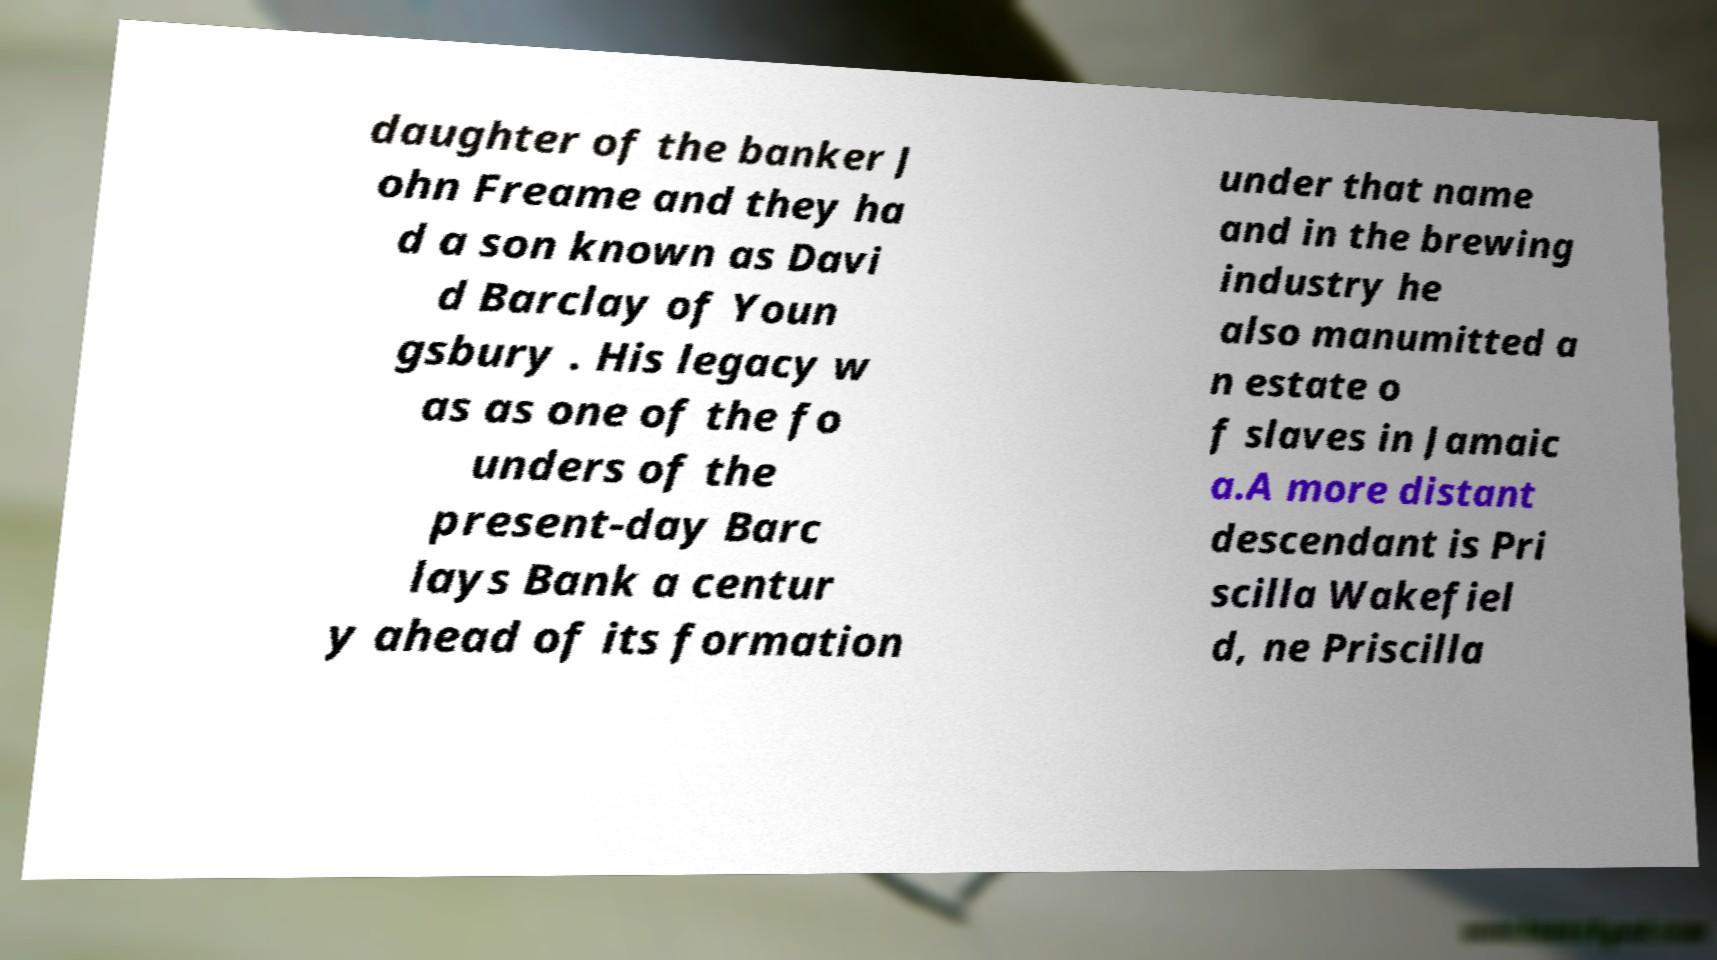Please identify and transcribe the text found in this image. daughter of the banker J ohn Freame and they ha d a son known as Davi d Barclay of Youn gsbury . His legacy w as as one of the fo unders of the present-day Barc lays Bank a centur y ahead of its formation under that name and in the brewing industry he also manumitted a n estate o f slaves in Jamaic a.A more distant descendant is Pri scilla Wakefiel d, ne Priscilla 